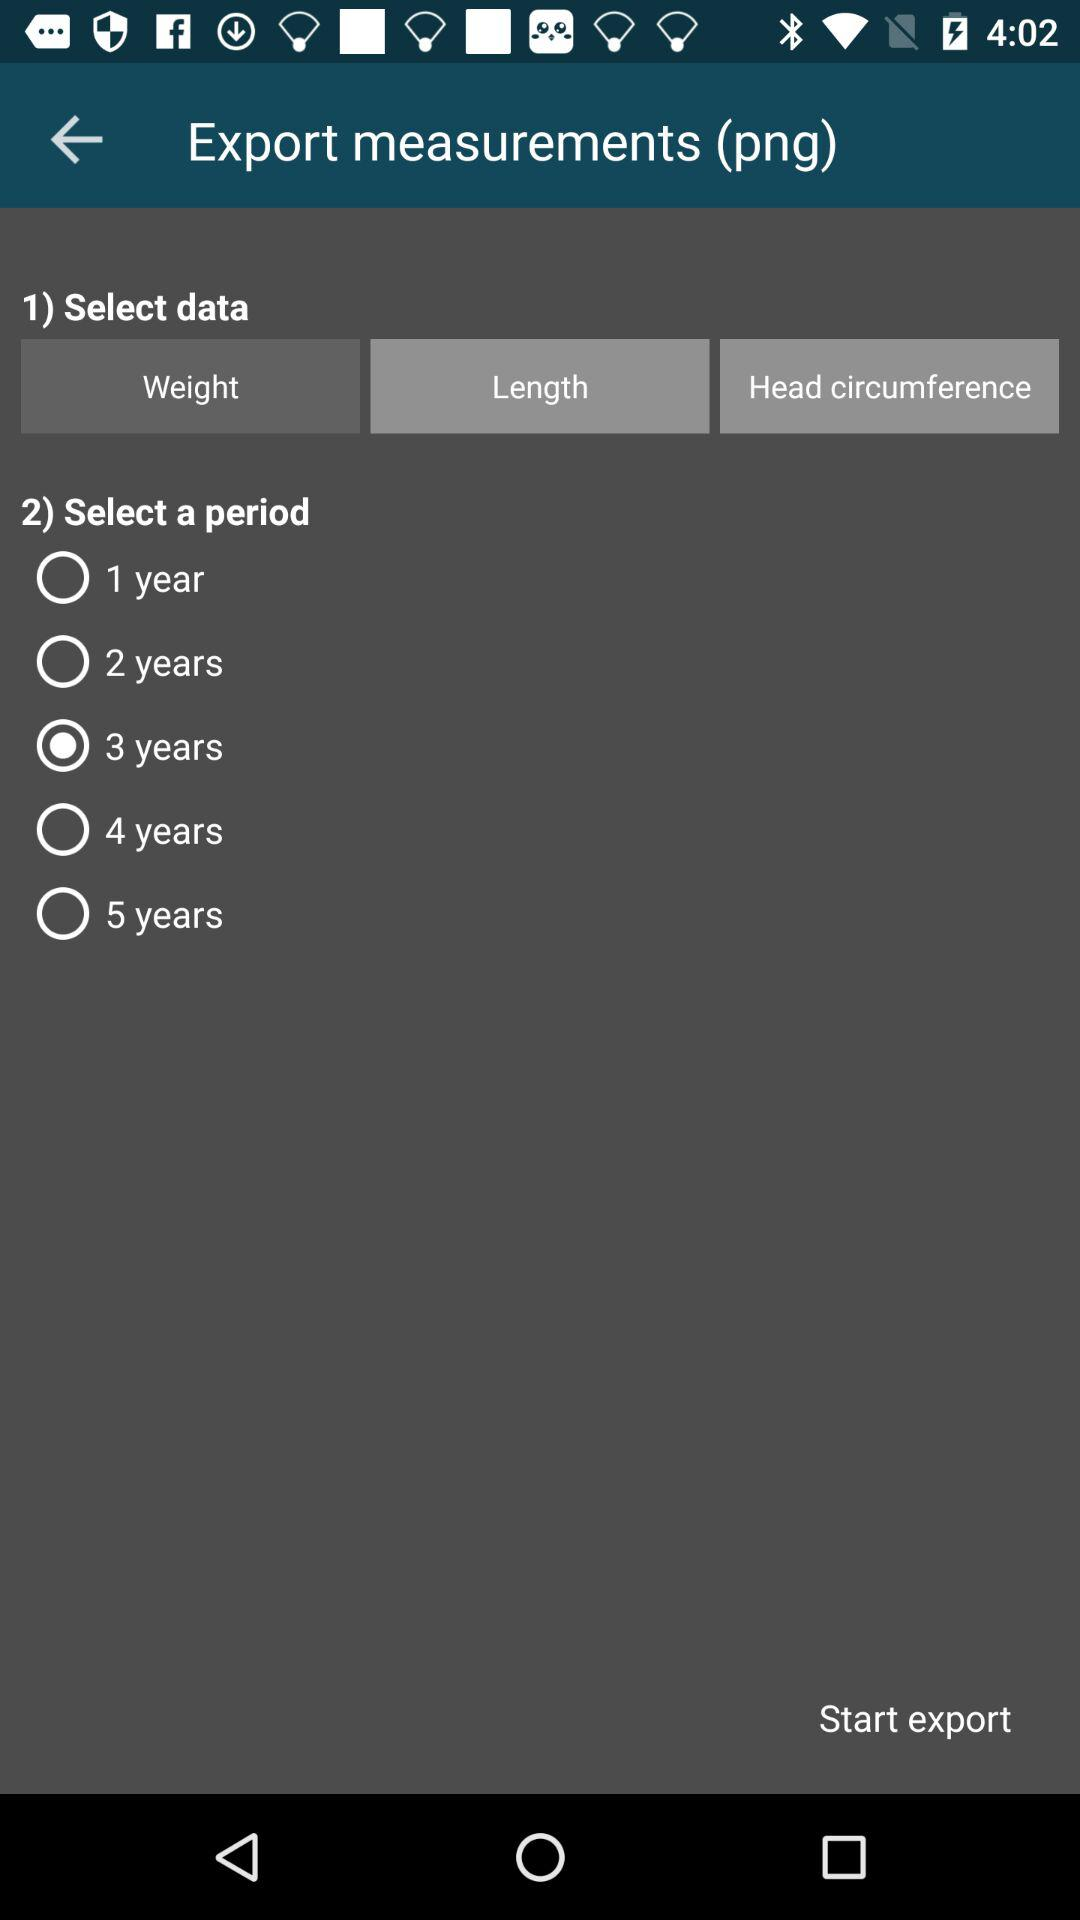How many years are available to select?
Answer the question using a single word or phrase. 5 